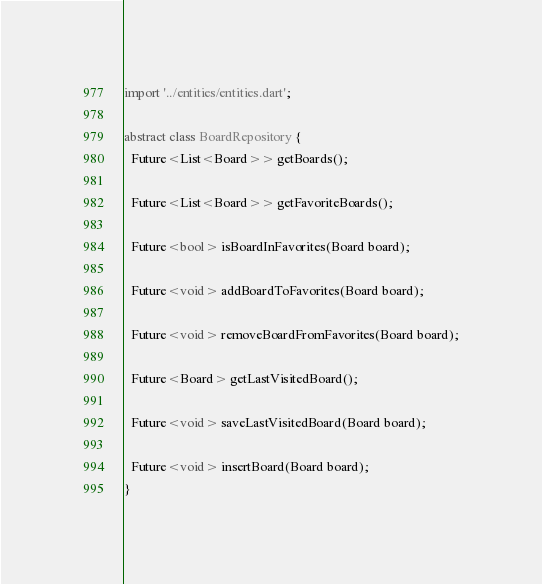<code> <loc_0><loc_0><loc_500><loc_500><_Dart_>import '../entities/entities.dart';

abstract class BoardRepository {
  Future<List<Board>> getBoards();

  Future<List<Board>> getFavoriteBoards();

  Future<bool> isBoardInFavorites(Board board);

  Future<void> addBoardToFavorites(Board board);

  Future<void> removeBoardFromFavorites(Board board);

  Future<Board> getLastVisitedBoard();

  Future<void> saveLastVisitedBoard(Board board);

  Future<void> insertBoard(Board board);
}
</code> 